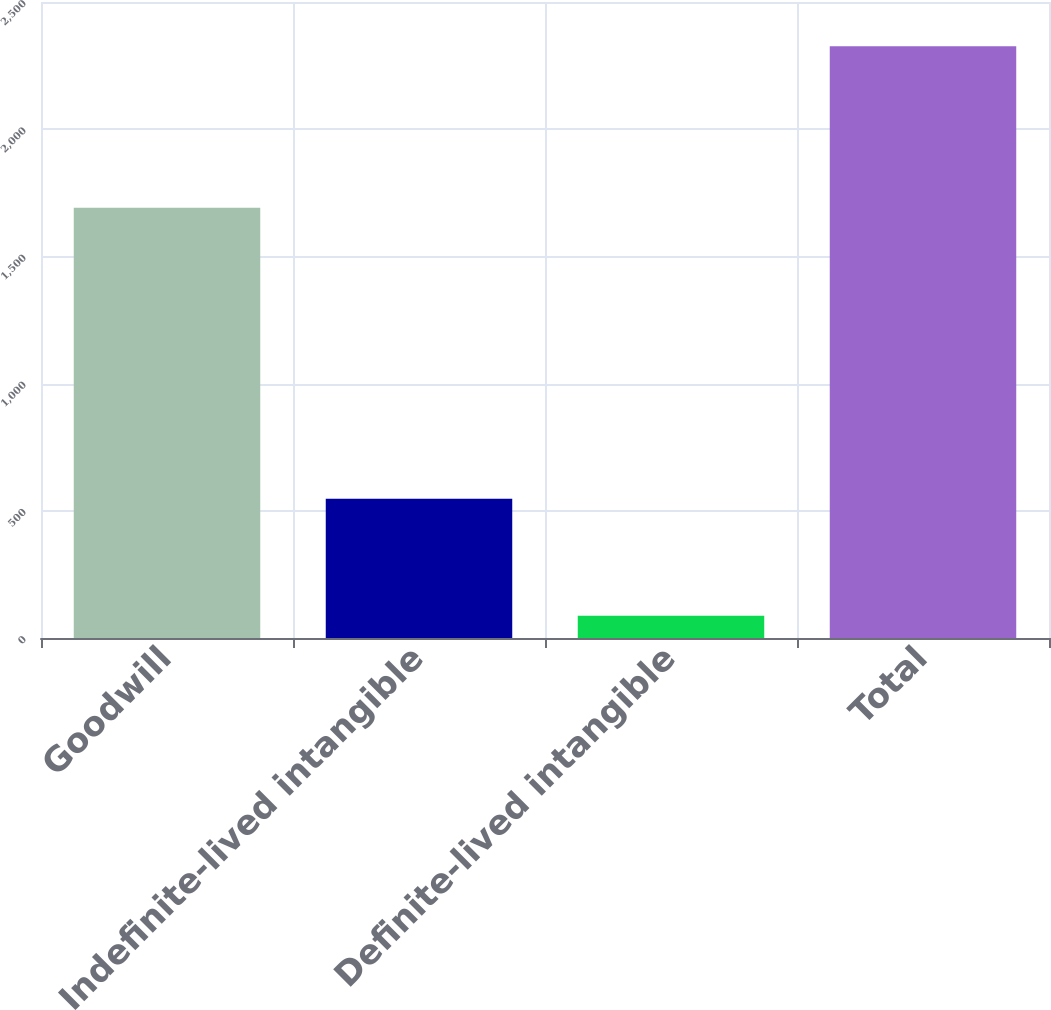Convert chart to OTSL. <chart><loc_0><loc_0><loc_500><loc_500><bar_chart><fcel>Goodwill<fcel>Indefinite-lived intangible<fcel>Definite-lived intangible<fcel>Total<nl><fcel>1691<fcel>547.4<fcel>87.5<fcel>2325.9<nl></chart> 